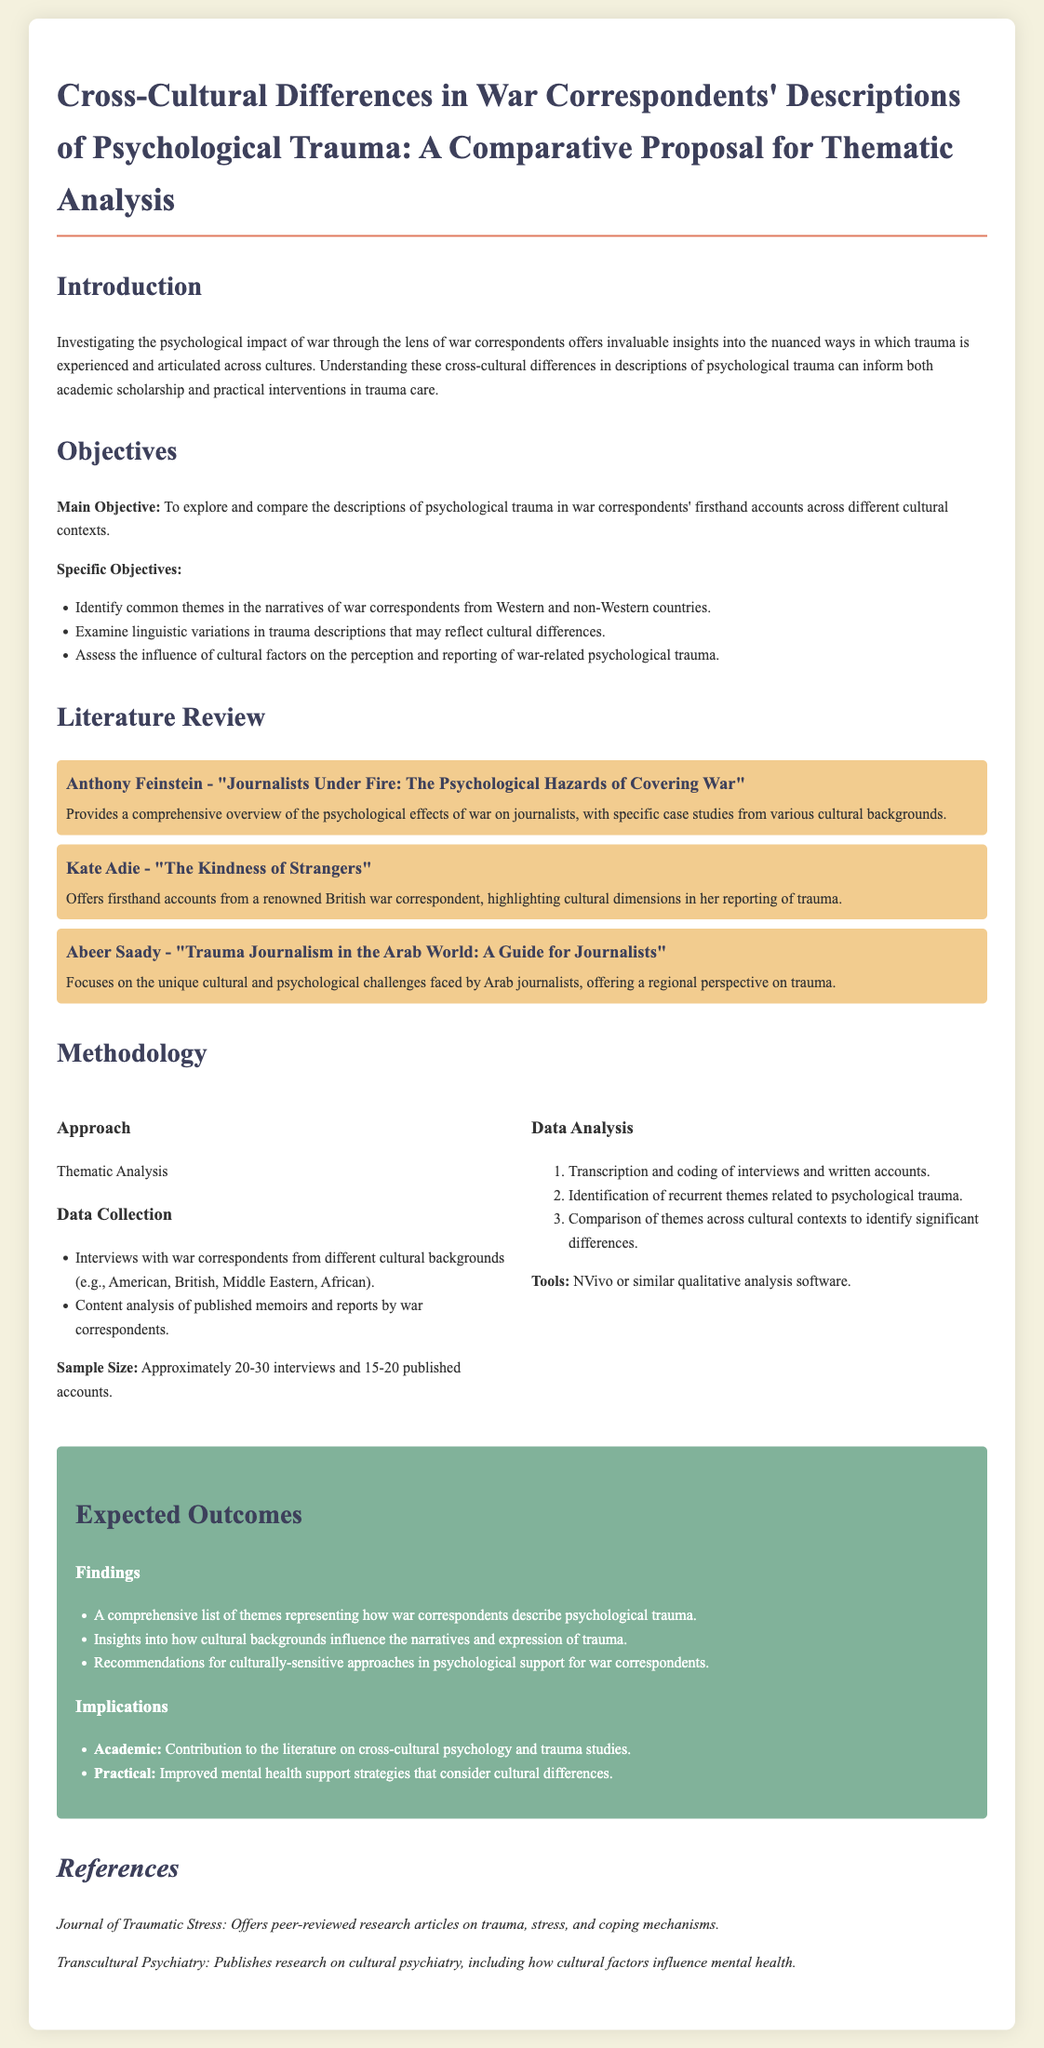what is the main objective of the study? The main objective is to explore and compare the descriptions of psychological trauma in war correspondents' firsthand accounts across different cultural contexts.
Answer: to explore and compare the descriptions of psychological trauma in war correspondents' firsthand accounts across different cultural contexts who is the author of "Journalists Under Fire: The Psychological Hazards of Covering War"? This book is authored by Anthony Feinstein, which is mentioned as a key source in the literature review.
Answer: Anthony Feinstein how many interviews are planned for data collection? The proposal states that approximately 20-30 interviews will be conducted as part of the data collection process.
Answer: approximately 20-30 interviews what analysis method will be used? The proposal indicates that Thematic Analysis will be the primary approach utilized in this research.
Answer: Thematic Analysis what are the expected academic implications of the findings? The expected academic implication includes contributing to the literature on cross-cultural psychology and trauma studies.
Answer: Contribution to the literature on cross-cultural psychology and trauma studies 